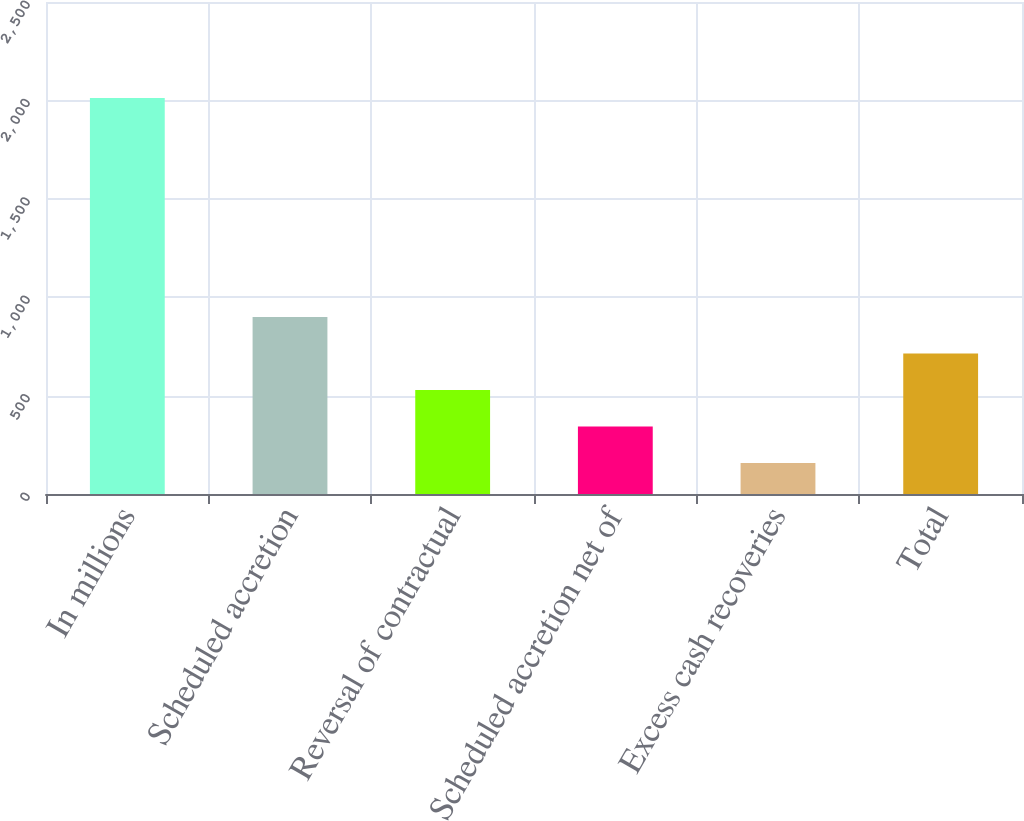Convert chart. <chart><loc_0><loc_0><loc_500><loc_500><bar_chart><fcel>In millions<fcel>Scheduled accretion<fcel>Reversal of contractual<fcel>Scheduled accretion net of<fcel>Excess cash recoveries<fcel>Total<nl><fcel>2012<fcel>899<fcel>528<fcel>342.5<fcel>157<fcel>713.5<nl></chart> 